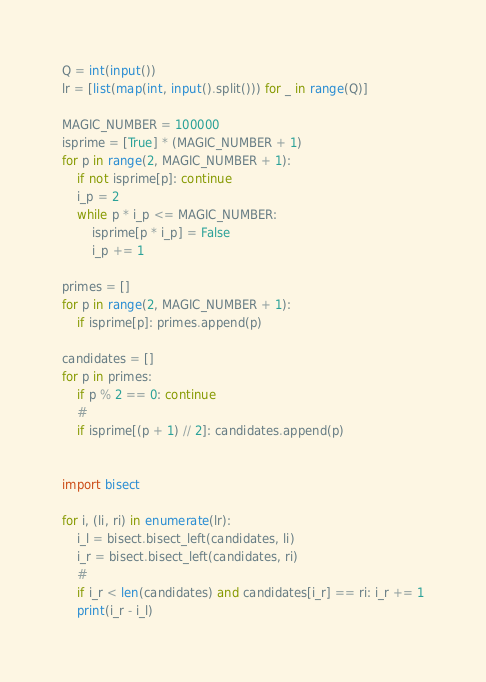Convert code to text. <code><loc_0><loc_0><loc_500><loc_500><_Python_>Q = int(input())
lr = [list(map(int, input().split())) for _ in range(Q)]

MAGIC_NUMBER = 100000
isprime = [True] * (MAGIC_NUMBER + 1)
for p in range(2, MAGIC_NUMBER + 1):
    if not isprime[p]: continue
    i_p = 2
    while p * i_p <= MAGIC_NUMBER:
        isprime[p * i_p] = False
        i_p += 1

primes = []
for p in range(2, MAGIC_NUMBER + 1):
    if isprime[p]: primes.append(p)

candidates = []
for p in primes:
    if p % 2 == 0: continue
    #
    if isprime[(p + 1) // 2]: candidates.append(p)


import bisect
    
for i, (li, ri) in enumerate(lr):
    i_l = bisect.bisect_left(candidates, li)
    i_r = bisect.bisect_left(candidates, ri)
    #
    if i_r < len(candidates) and candidates[i_r] == ri: i_r += 1
    print(i_r - i_l)</code> 